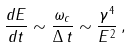Convert formula to latex. <formula><loc_0><loc_0><loc_500><loc_500>\frac { d E } { d t } \sim \frac { \omega _ { c } } { \Delta \, t } \sim \frac { \gamma ^ { 4 } } { E ^ { 2 } } \, ,</formula> 